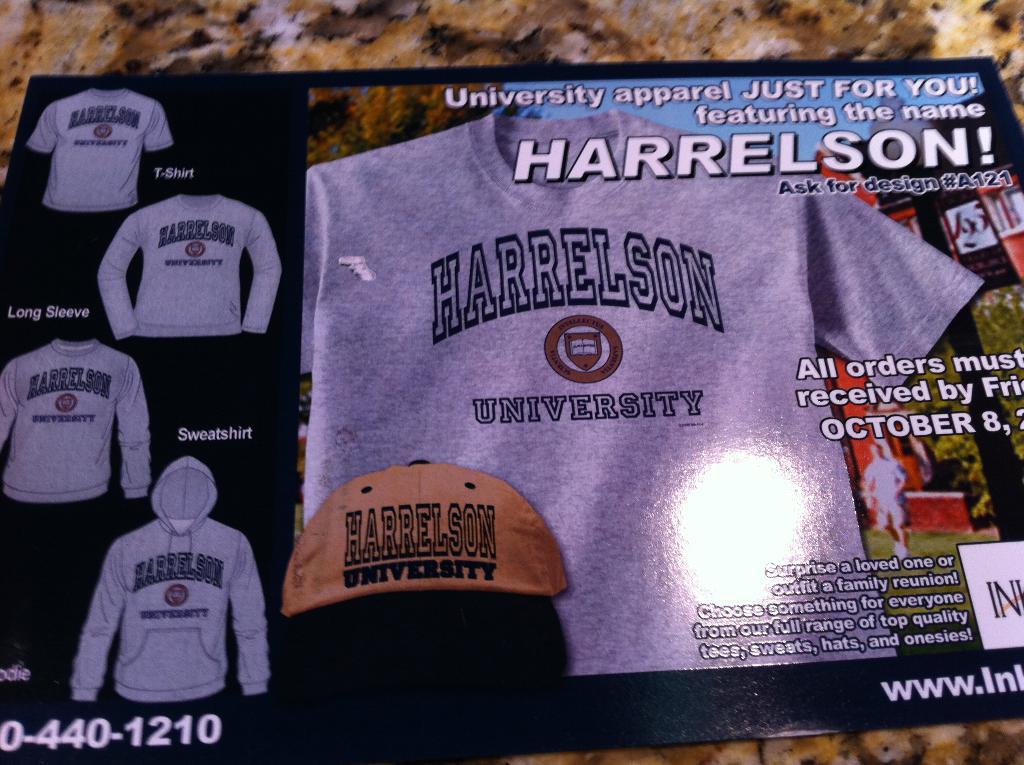What university are all these clothing from?
Keep it short and to the point. Harrelson. 